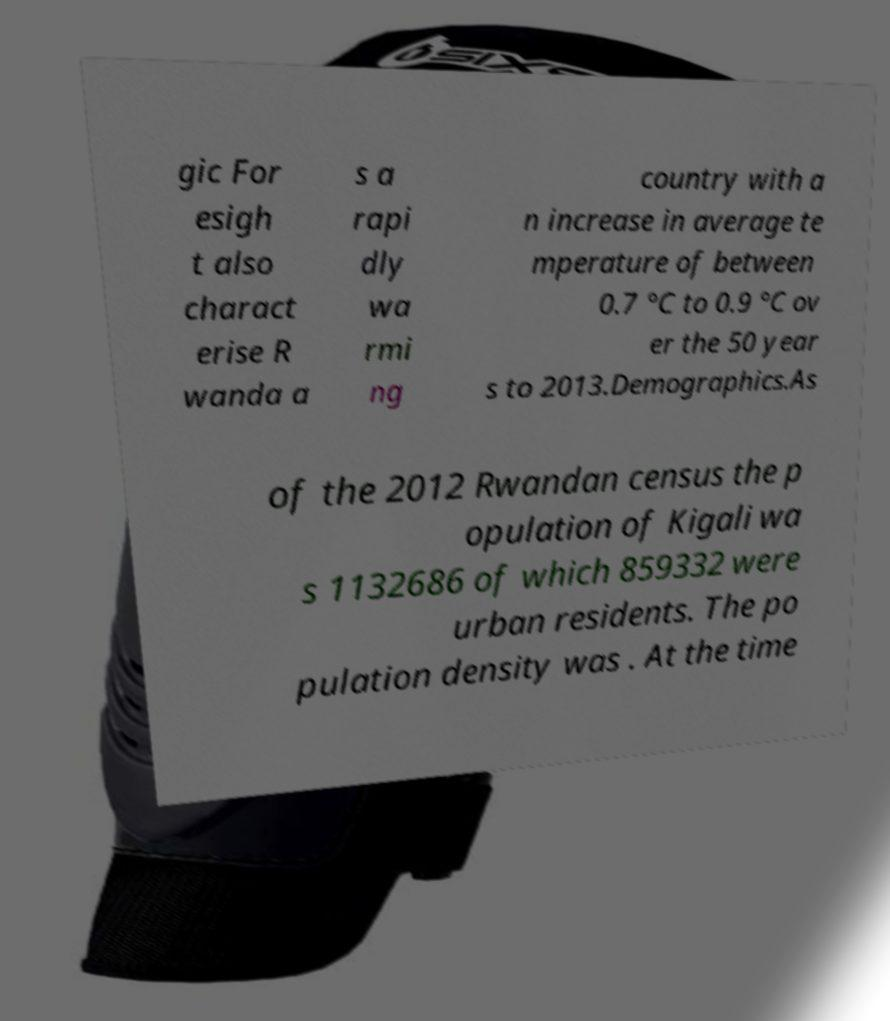I need the written content from this picture converted into text. Can you do that? gic For esigh t also charact erise R wanda a s a rapi dly wa rmi ng country with a n increase in average te mperature of between 0.7 °C to 0.9 °C ov er the 50 year s to 2013.Demographics.As of the 2012 Rwandan census the p opulation of Kigali wa s 1132686 of which 859332 were urban residents. The po pulation density was . At the time 